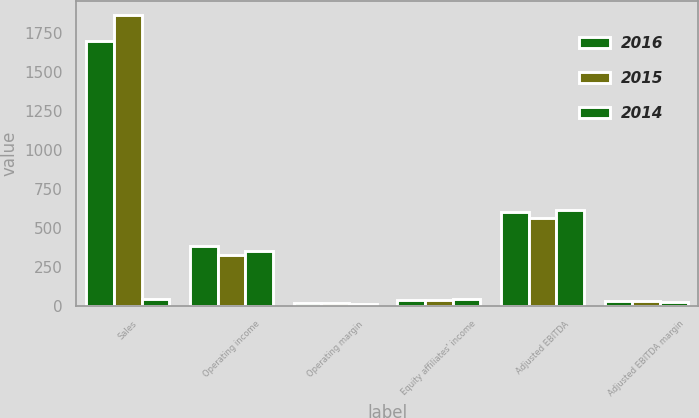Convert chart. <chart><loc_0><loc_0><loc_500><loc_500><stacked_bar_chart><ecel><fcel>Sales<fcel>Operating income<fcel>Operating margin<fcel>Equity affiliates' income<fcel>Adjusted EBITDA<fcel>Adjusted EBITDA margin<nl><fcel>2016<fcel>1700.3<fcel>382.8<fcel>22.5<fcel>36.5<fcel>605<fcel>35.6<nl><fcel>2015<fcel>1864.9<fcel>330.7<fcel>17.7<fcel>42.4<fcel>567.4<fcel>30.4<nl><fcel>2014<fcel>44.1<fcel>351.2<fcel>16.3<fcel>44.1<fcel>615.5<fcel>28.6<nl></chart> 